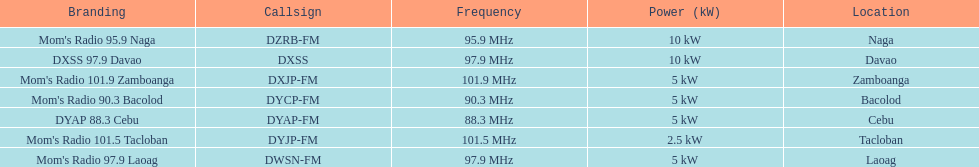What is the radio with the most mhz? Mom's Radio 101.9 Zamboanga. 